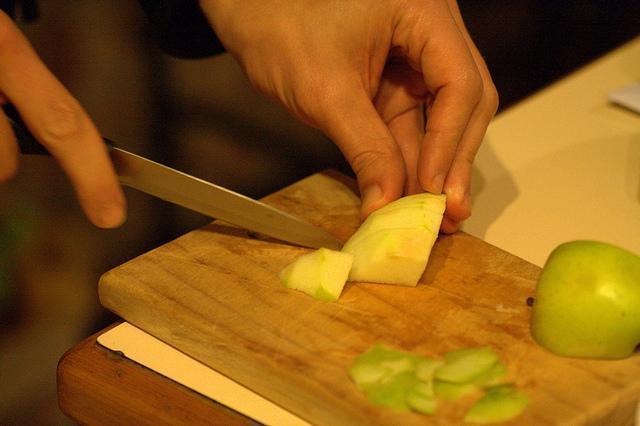What is this type of apple called?
Make your selection and explain in format: 'Answer: answer
Rationale: rationale.'
Options: Ladybug, granny smith, red delicious, baking. Answer: granny smith.
Rationale: The apple is small and green. 